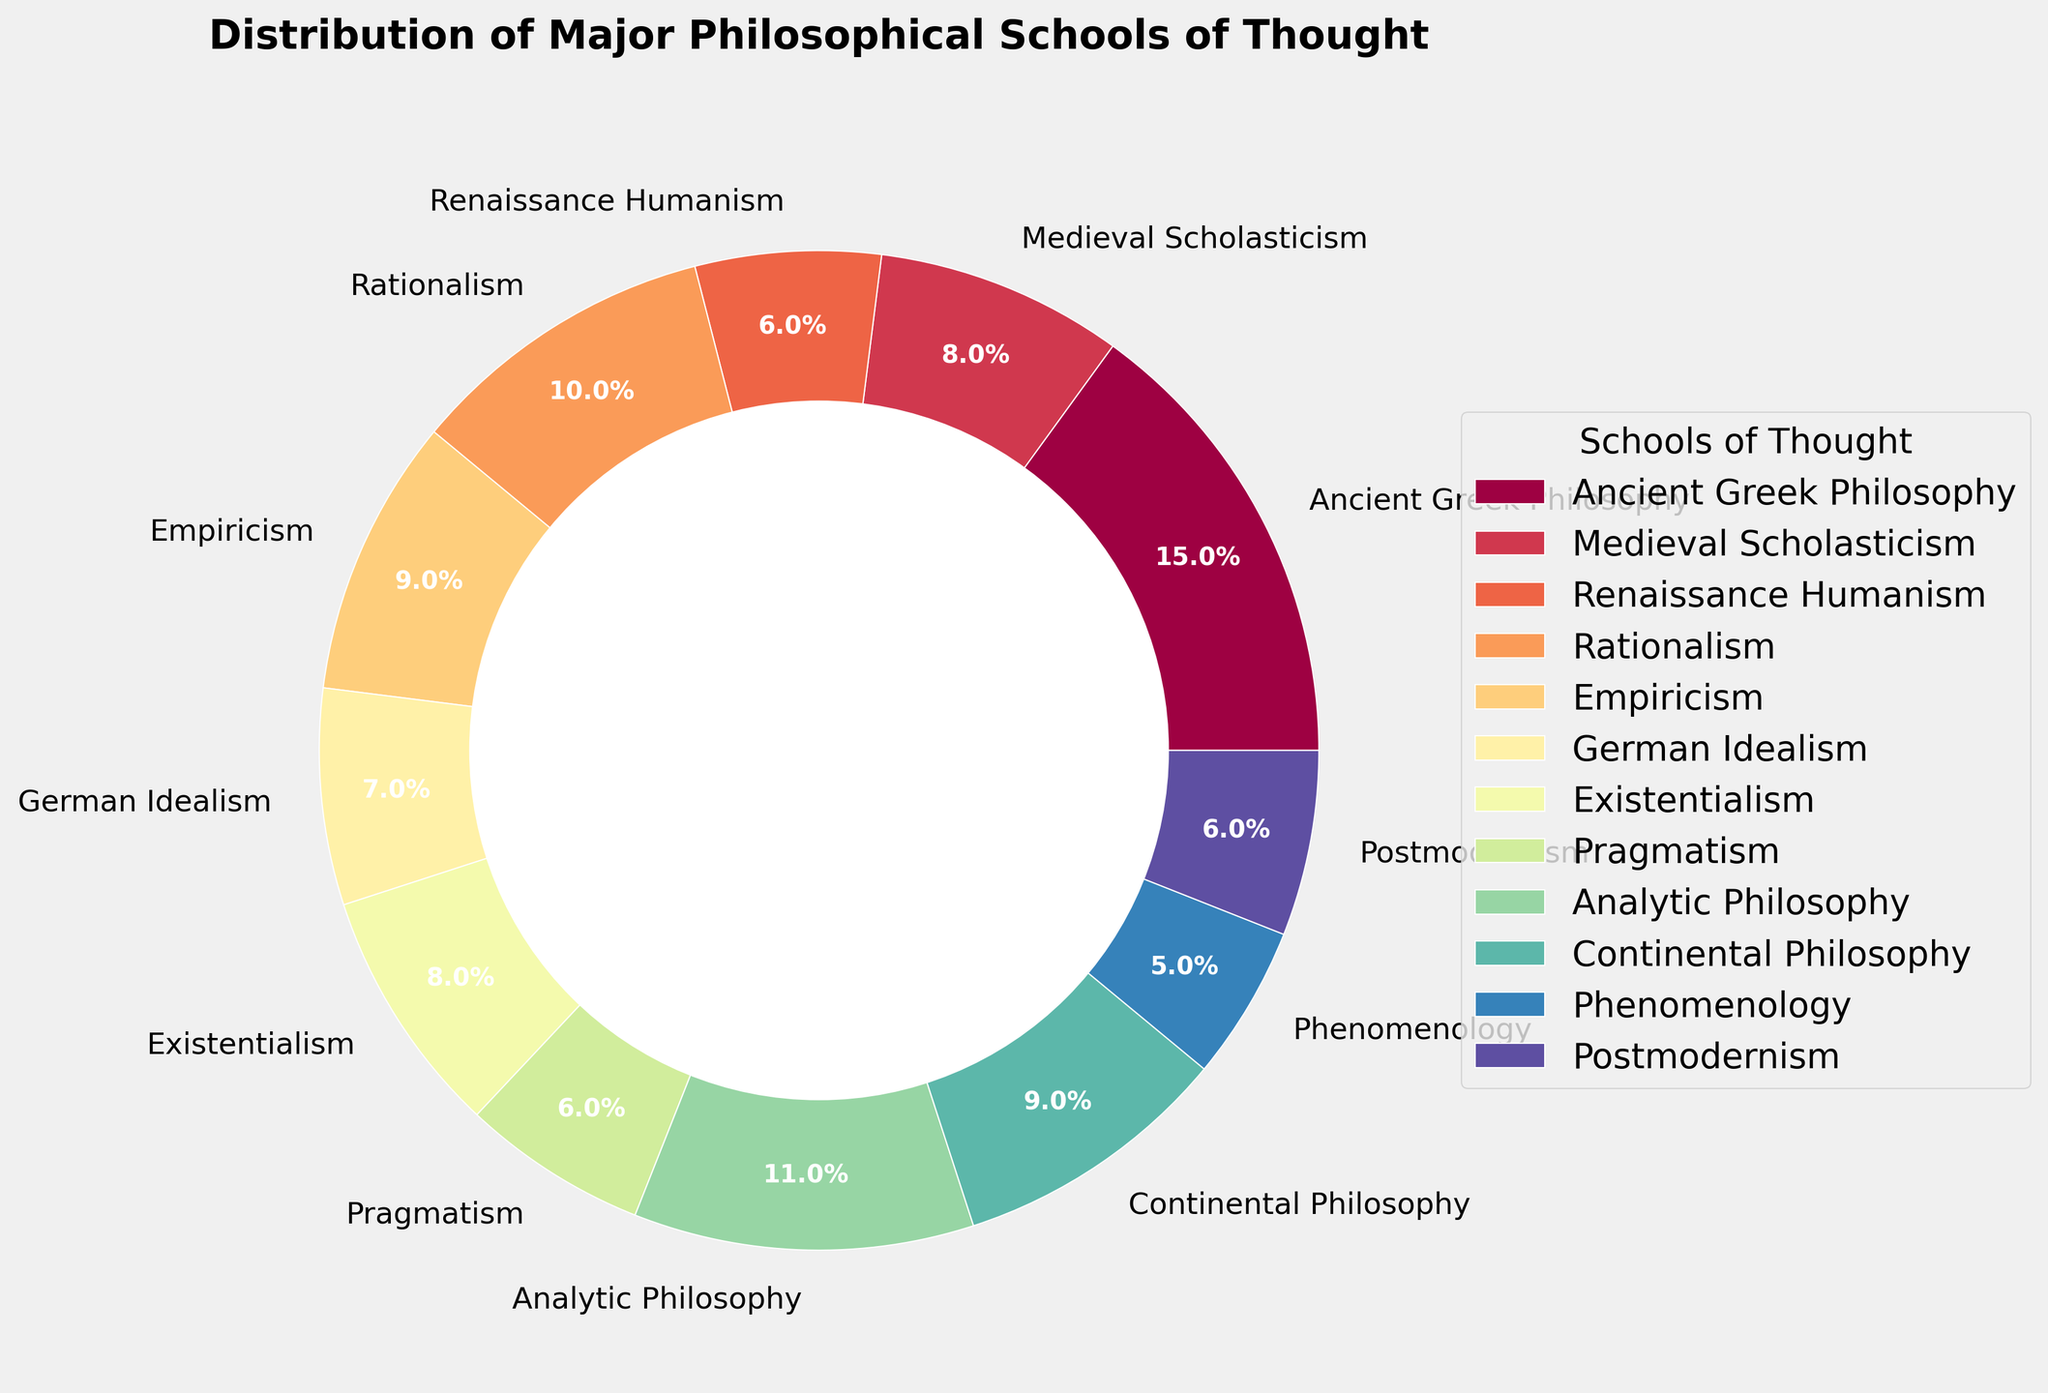Which school of thought has the highest percentage? The chart displays the distribution percentages of various philosophical schools. By observing the sizes of the wedges in the pie chart, we can see that Ancient Greek Philosophy has the highest percentage.
Answer: Ancient Greek Philosophy Which school of thought has the lowest percentage? By looking at the chart, we can identify the smallest wedge, which corresponds to Phenomenology.
Answer: Phenomenology What is the combined percentage of Renaissance Humanism, Pragmatism, and Postmodernism? To find the combined percentage, sum the individual percentages of these schools: 6% (Renaissance Humanism) + 6% (Pragmatism) + 6% (Postmodernism) = 18%.
Answer: 18% Which has a greater percentage, Rationalism or Empiricism, and by how much? Rationalism has 10% and Empiricism has 9%. The difference is 10% - 9% = 1%.
Answer: Rationalism by 1% What is the average percentage of Existentialism, Pragmatism, and Phenomenology? To find the average, sum the percentages of these schools and divide by the number of schools: (8% + 6% + 5%) / 3 = 19% / 3 ≈ 6.33%.
Answer: 6.33% How many schools have a percentage equal to or greater than 10%? The schools of thought with percentages equal to or greater than 10% are Ancient Greek Philosophy (15%), Rationalism (10%), and Analytic Philosophy (11%). This makes a total of 3 schools.
Answer: 3 Which two schools of thought together make up more than 20%? By adding the percentages of different schools, we find that Ancient Greek Philosophy (15%) + Rationalism (10%) = 25%, which is greater than 20%.
Answer: Ancient Greek Philosophy and Rationalism What is the median percentage of all the schools of thought? To find the median, list out all percentages in ascending order: 5%, 6%, 6%, 6%, 7%, 8%, 8%, 9%, 9%, 10%, 11%, 15%. The median is the average of the 6th (8%) and 7th (8%) values: (8% + 8%) / 2 = 8%.
Answer: 8% Which school of thought's wedge appears in the green part of the spectrum? The color palette used in the chart varies from spectral tones. The green-toned wedge falls around German Idealism based on the design of the color palette.
Answer: German Idealism 